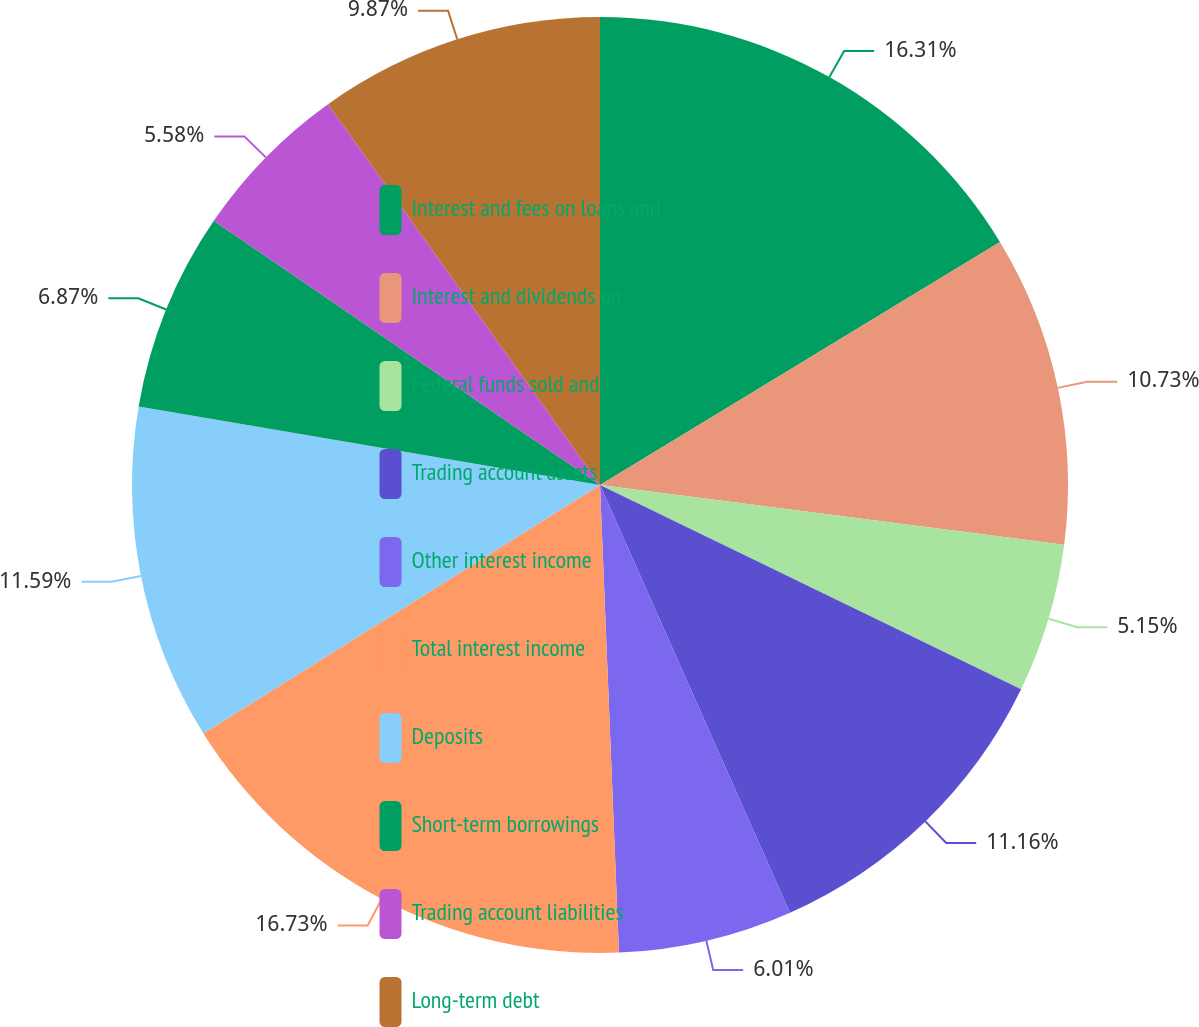Convert chart to OTSL. <chart><loc_0><loc_0><loc_500><loc_500><pie_chart><fcel>Interest and fees on loans and<fcel>Interest and dividends on<fcel>Federal funds sold and<fcel>Trading account assets<fcel>Other interest income<fcel>Total interest income<fcel>Deposits<fcel>Short-term borrowings<fcel>Trading account liabilities<fcel>Long-term debt<nl><fcel>16.31%<fcel>10.73%<fcel>5.15%<fcel>11.16%<fcel>6.01%<fcel>16.74%<fcel>11.59%<fcel>6.87%<fcel>5.58%<fcel>9.87%<nl></chart> 